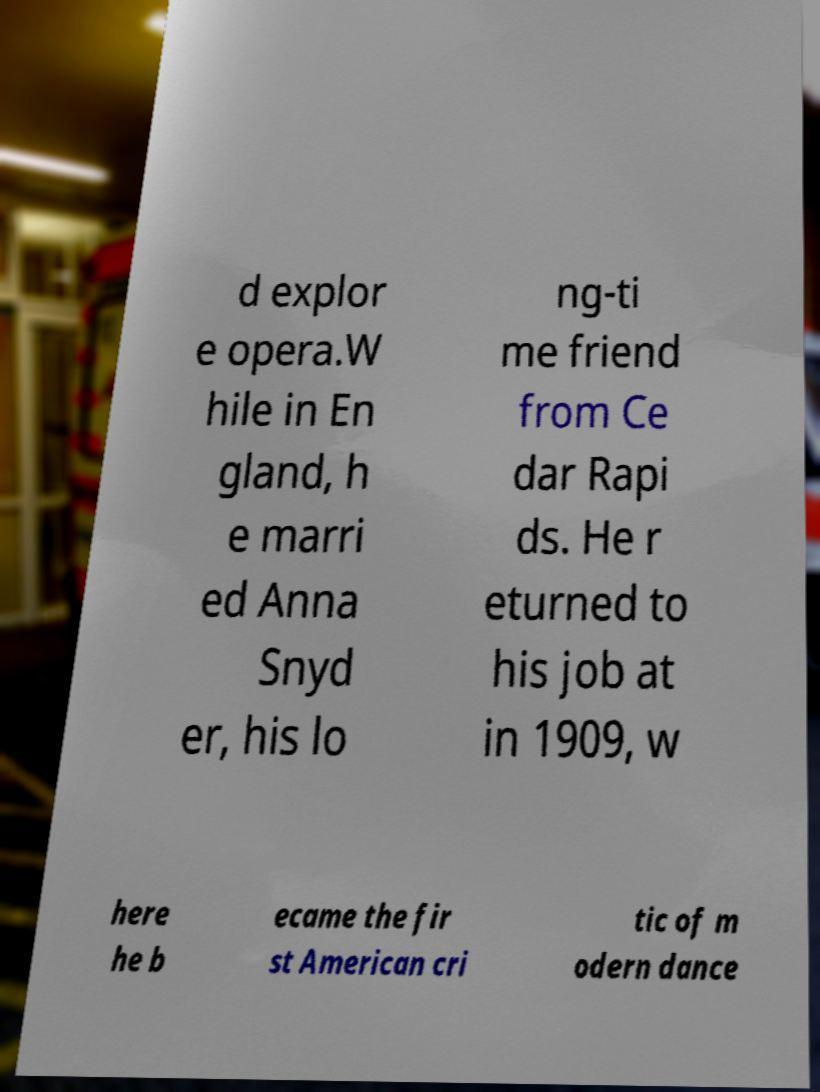Please read and relay the text visible in this image. What does it say? d explor e opera.W hile in En gland, h e marri ed Anna Snyd er, his lo ng-ti me friend from Ce dar Rapi ds. He r eturned to his job at in 1909, w here he b ecame the fir st American cri tic of m odern dance 